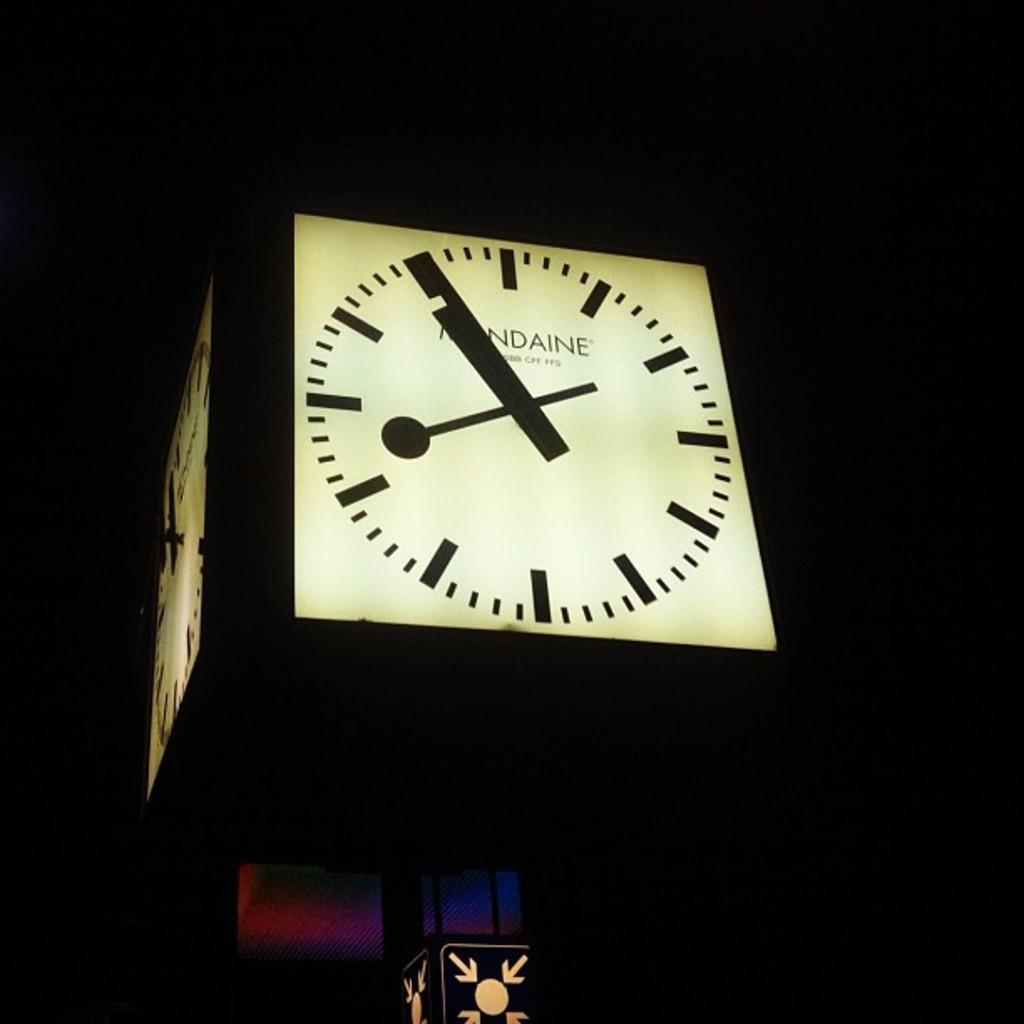<image>
Provide a brief description of the given image. A black and white light up clock that says something-daine on it. 